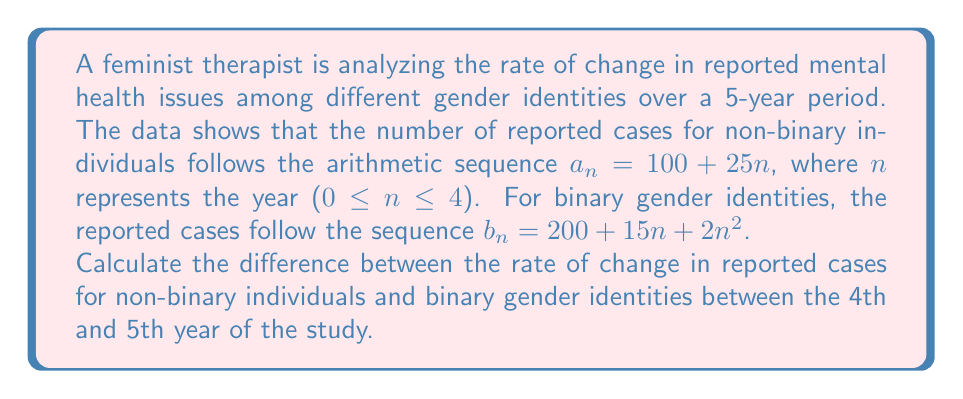Solve this math problem. To solve this problem, we need to follow these steps:

1. Find the rate of change for non-binary individuals:
   The sequence $a_n = 100 + 25n$ is arithmetic, so the rate of change is constant.
   Rate of change = $25$ cases per year

2. Find the rate of change for binary gender identities:
   For the sequence $b_n = 200 + 15n + 2n^2$, we need to calculate the difference between the 4th and 5th year.
   
   For n = 3 (4th year): $b_3 = 200 + 15(3) + 2(3^2) = 200 + 45 + 18 = 263$
   For n = 4 (5th year): $b_4 = 200 + 15(4) + 2(4^2) = 200 + 60 + 32 = 292$
   
   Rate of change = $292 - 263 = 29$ cases per year

3. Calculate the difference between the rates of change:
   Difference = Rate for binary - Rate for non-binary
               = $29 - 25 = 4$ cases per year

This result indicates that between the 4th and 5th year, the rate of increase in reported mental health issues for binary gender identities is 4 cases per year higher than for non-binary individuals.
Answer: The difference in the rate of change between binary and non-binary gender identities is 4 cases per year. 